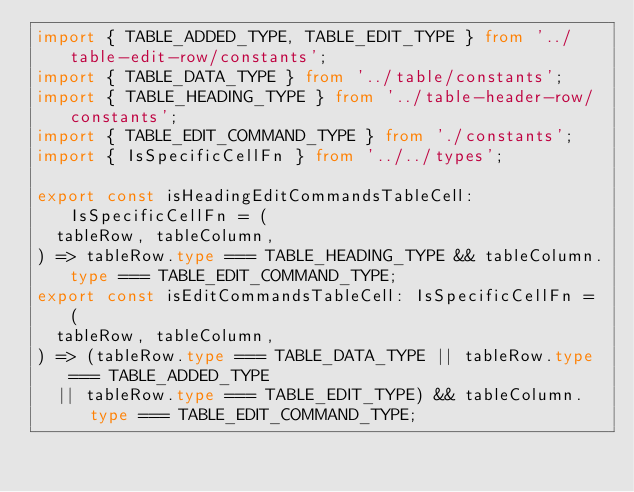Convert code to text. <code><loc_0><loc_0><loc_500><loc_500><_TypeScript_>import { TABLE_ADDED_TYPE, TABLE_EDIT_TYPE } from '../table-edit-row/constants';
import { TABLE_DATA_TYPE } from '../table/constants';
import { TABLE_HEADING_TYPE } from '../table-header-row/constants';
import { TABLE_EDIT_COMMAND_TYPE } from './constants';
import { IsSpecificCellFn } from '../../types';

export const isHeadingEditCommandsTableCell: IsSpecificCellFn = (
  tableRow, tableColumn,
) => tableRow.type === TABLE_HEADING_TYPE && tableColumn.type === TABLE_EDIT_COMMAND_TYPE;
export const isEditCommandsTableCell: IsSpecificCellFn = (
  tableRow, tableColumn,
) => (tableRow.type === TABLE_DATA_TYPE || tableRow.type === TABLE_ADDED_TYPE
  || tableRow.type === TABLE_EDIT_TYPE) && tableColumn.type === TABLE_EDIT_COMMAND_TYPE;
</code> 